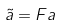Convert formula to latex. <formula><loc_0><loc_0><loc_500><loc_500>\tilde { a } = F a</formula> 